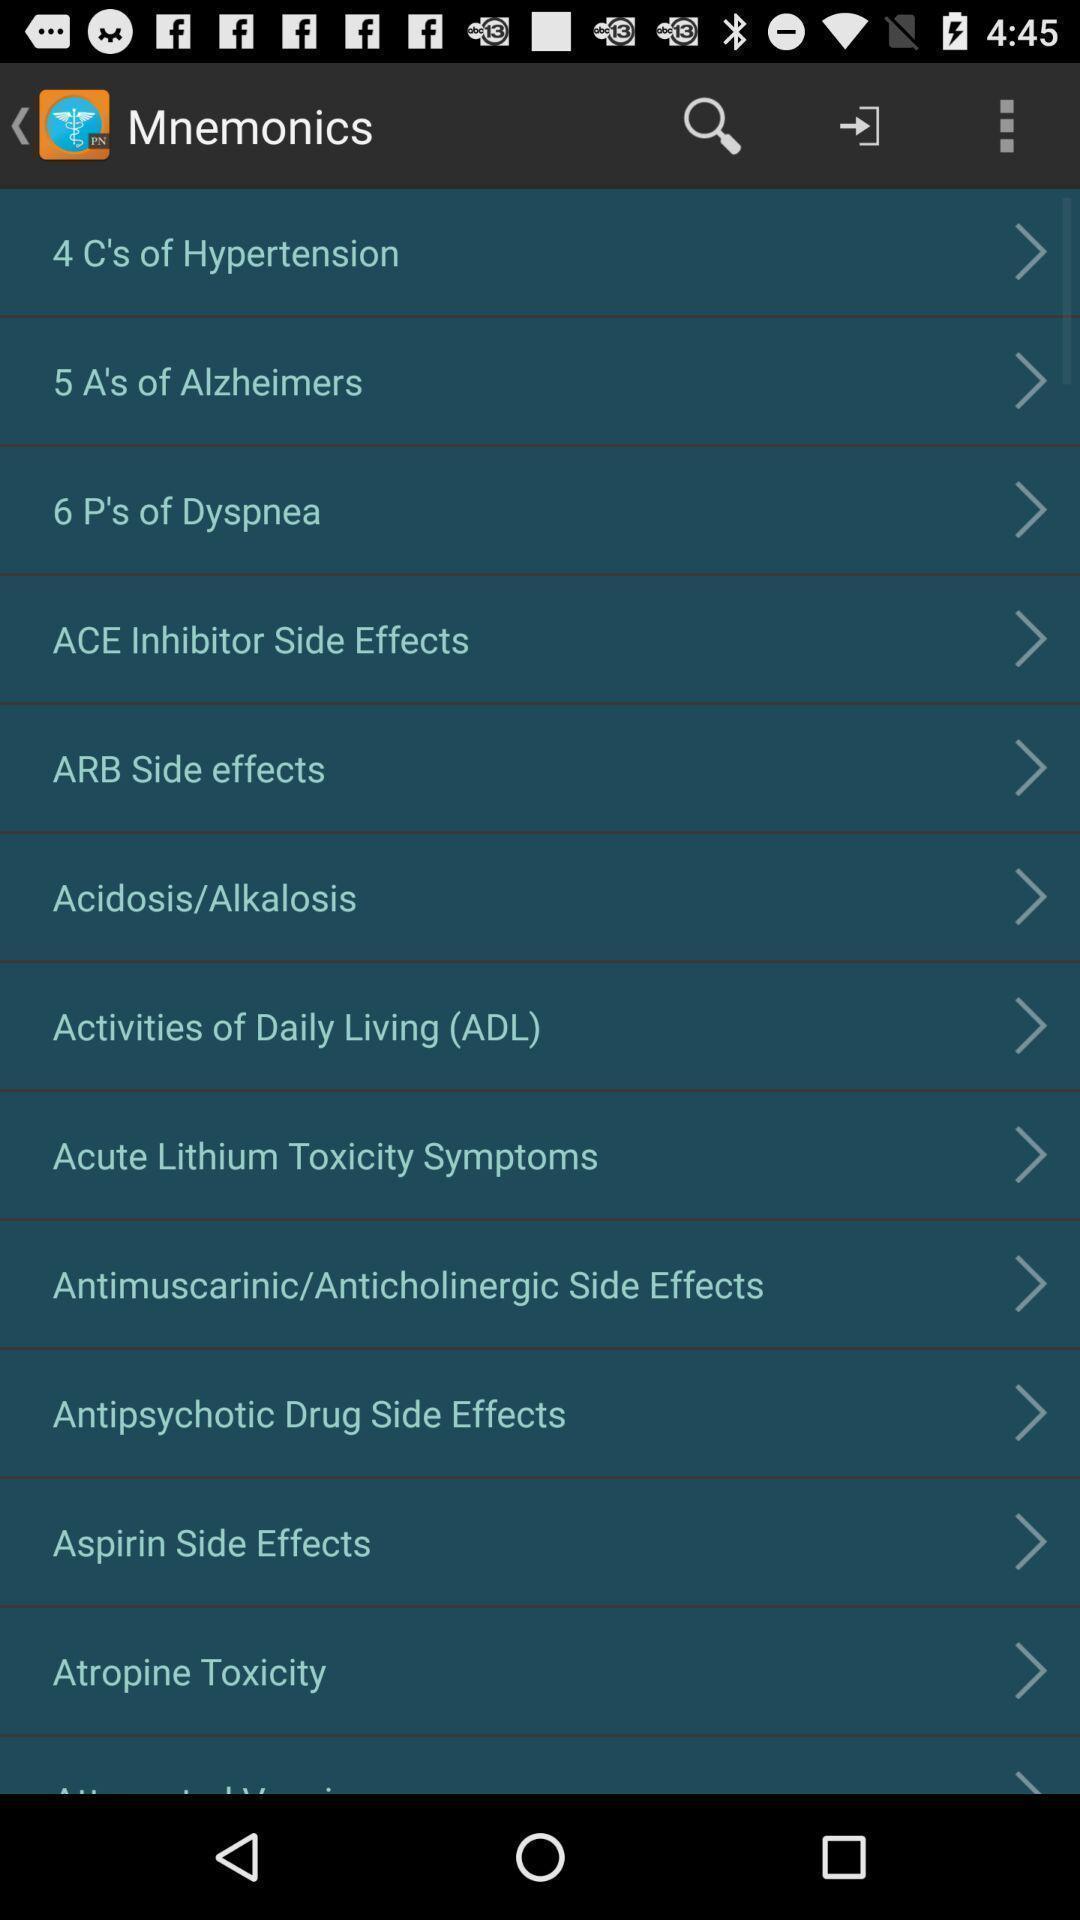Please provide a description for this image. Page showing topics. 